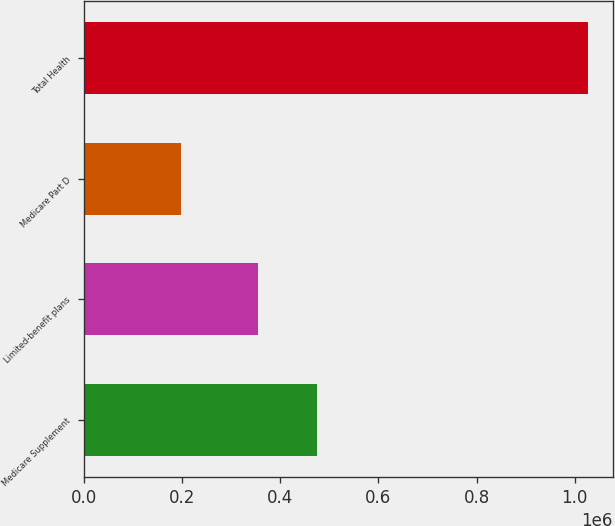Convert chart. <chart><loc_0><loc_0><loc_500><loc_500><bar_chart><fcel>Medicare Supplement<fcel>Limited-benefit plans<fcel>Medicare Part D<fcel>Total Health<nl><fcel>474987<fcel>354254<fcel>197319<fcel>1.02656e+06<nl></chart> 